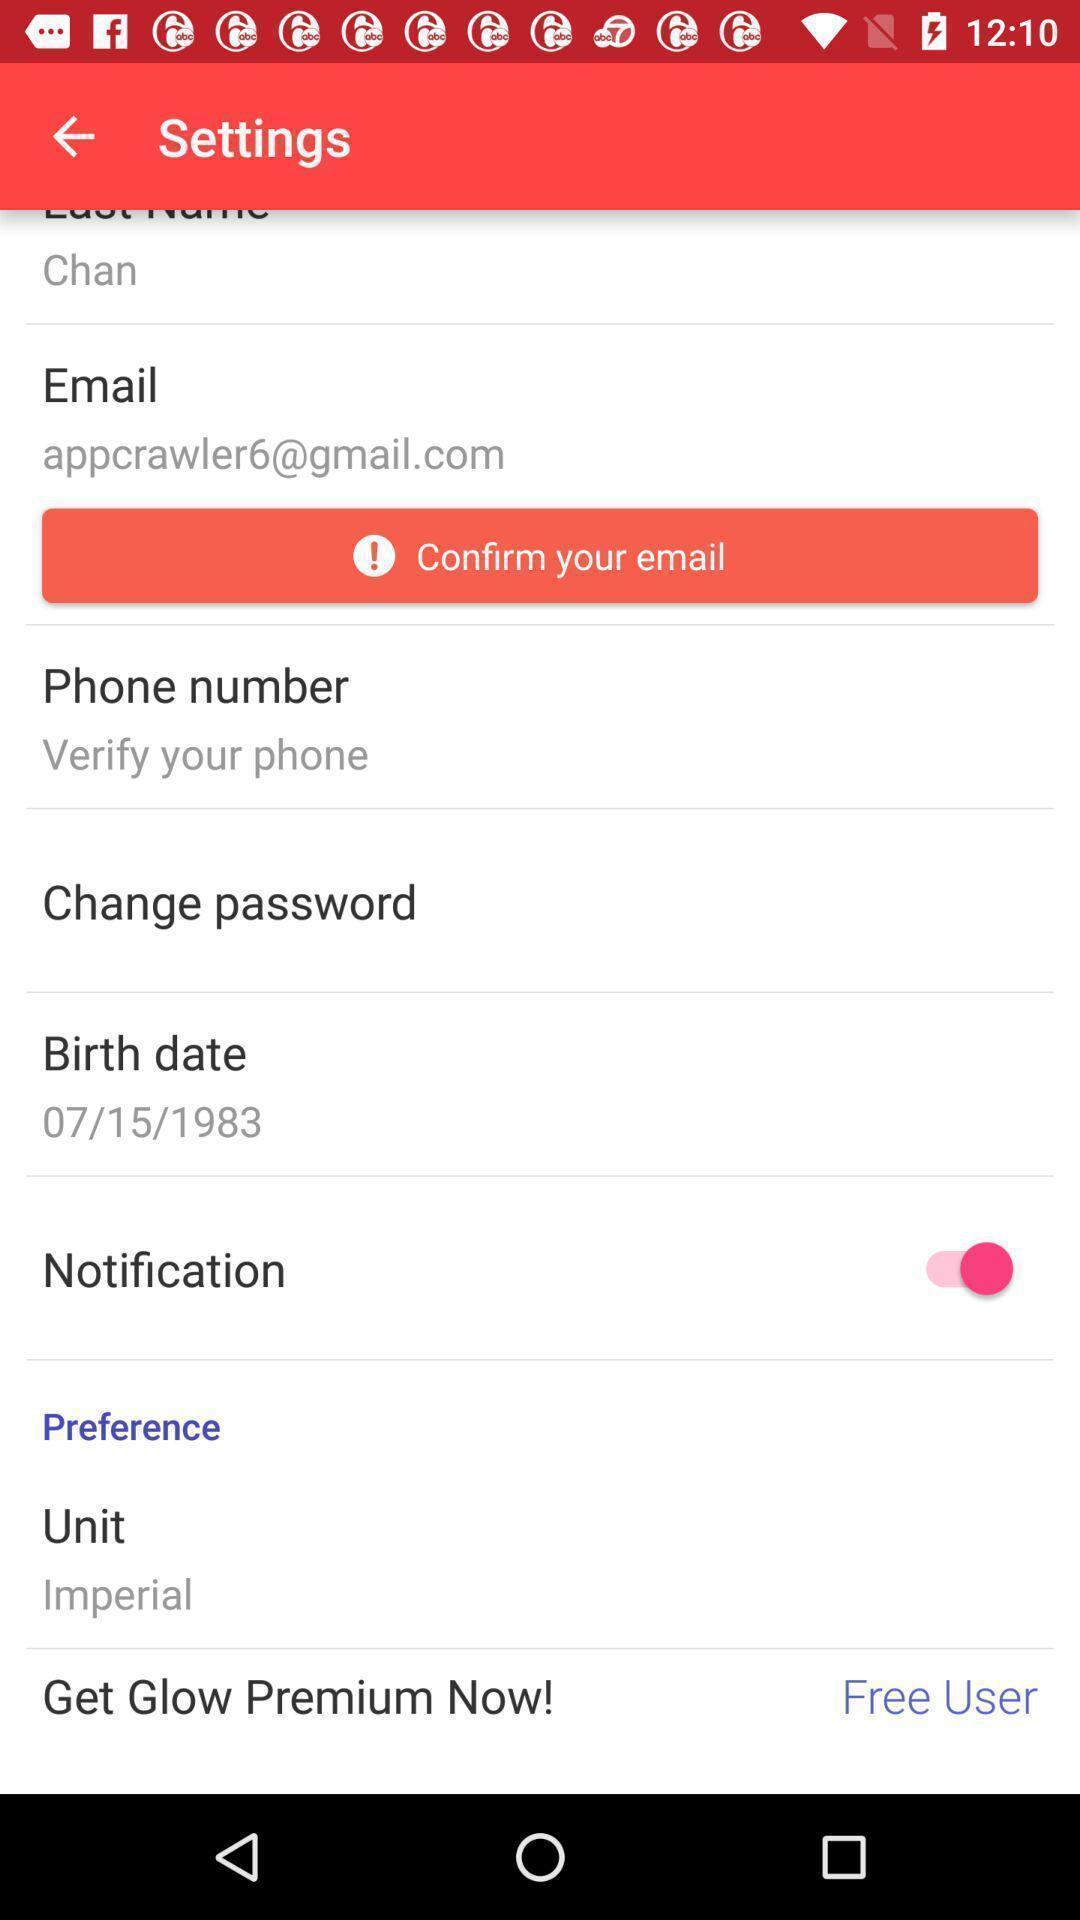What details can you identify in this image? Setting page displaying various options. 